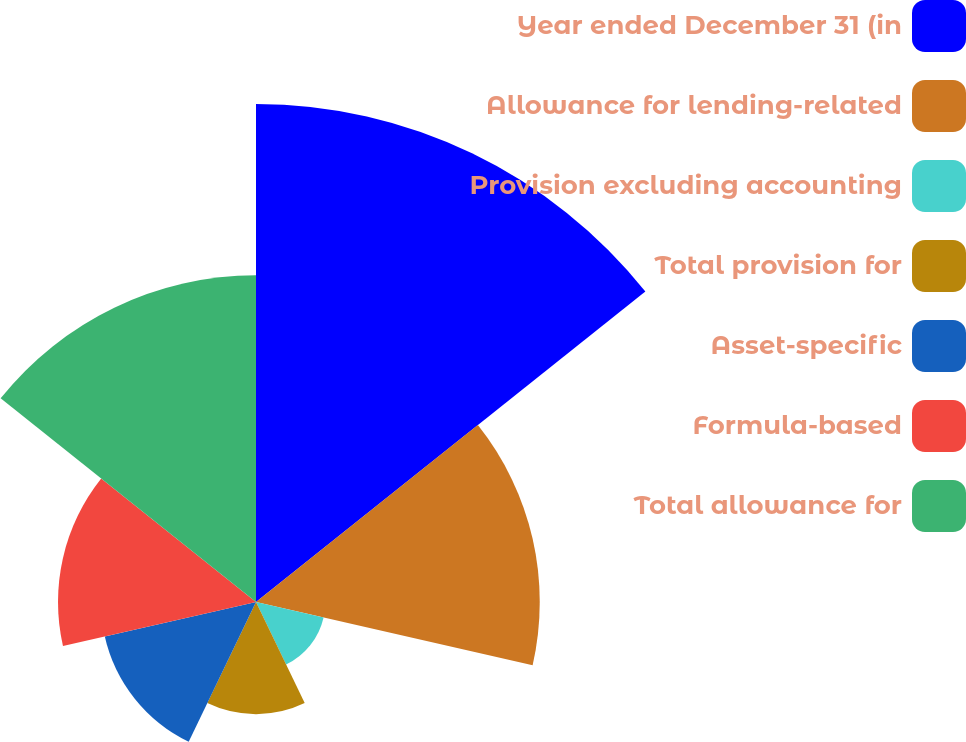Convert chart to OTSL. <chart><loc_0><loc_0><loc_500><loc_500><pie_chart><fcel>Year ended December 31 (in<fcel>Allowance for lending-related<fcel>Provision excluding accounting<fcel>Total provision for<fcel>Asset-specific<fcel>Formula-based<fcel>Total allowance for<nl><fcel>30.31%<fcel>17.27%<fcel>4.22%<fcel>6.83%<fcel>9.44%<fcel>12.05%<fcel>19.88%<nl></chart> 